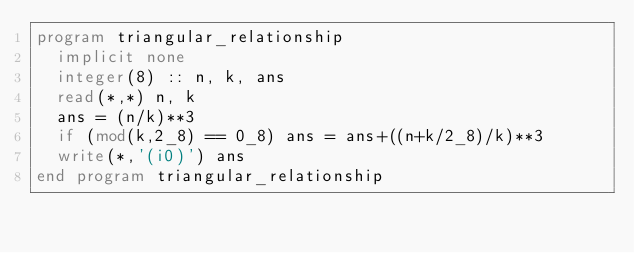<code> <loc_0><loc_0><loc_500><loc_500><_FORTRAN_>program triangular_relationship
  implicit none
  integer(8) :: n, k, ans
  read(*,*) n, k
  ans = (n/k)**3
  if (mod(k,2_8) == 0_8) ans = ans+((n+k/2_8)/k)**3
  write(*,'(i0)') ans
end program triangular_relationship</code> 